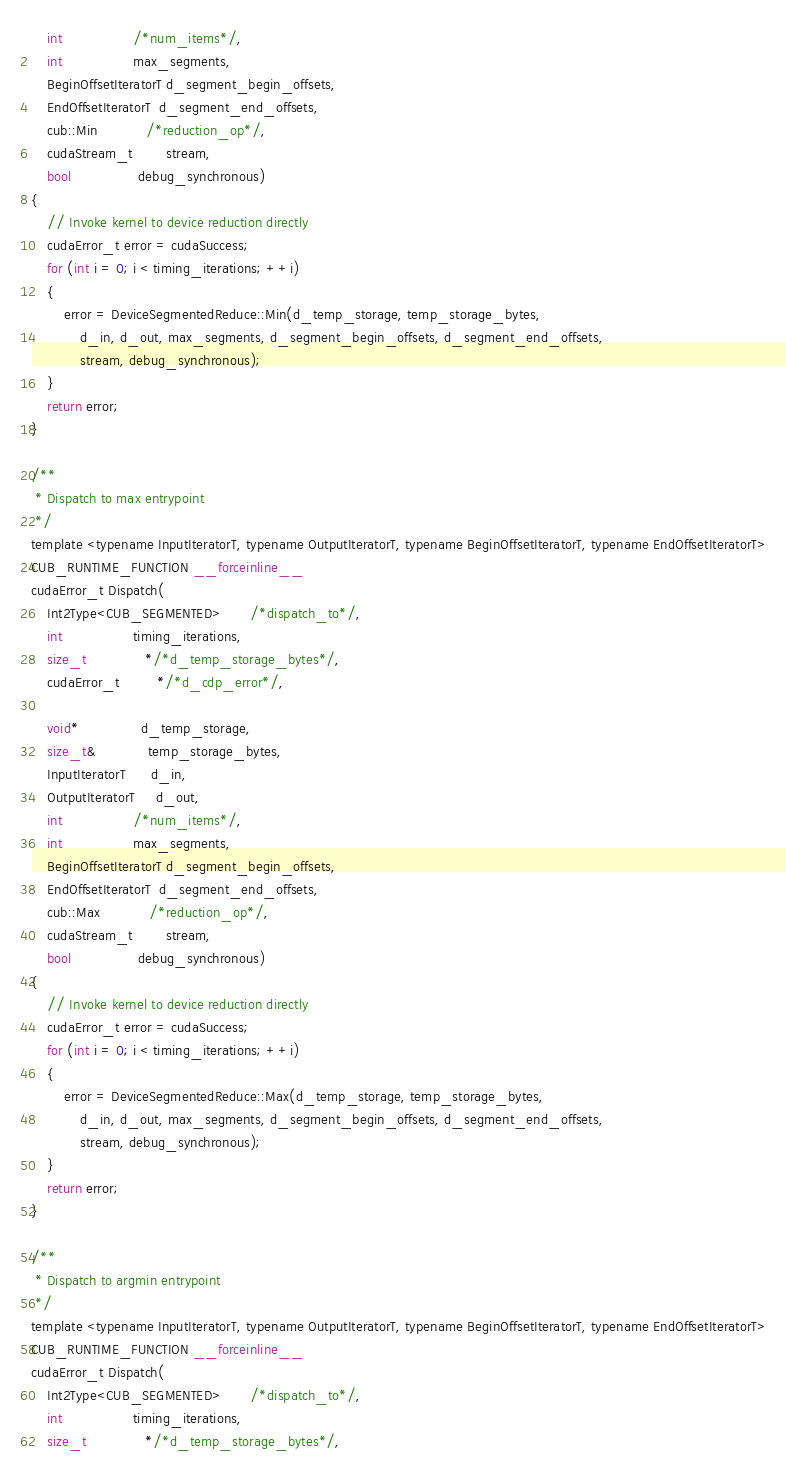<code> <loc_0><loc_0><loc_500><loc_500><_Cuda_>    int                 /*num_items*/,
    int                 max_segments,
    BeginOffsetIteratorT d_segment_begin_offsets,
    EndOffsetIteratorT  d_segment_end_offsets,
    cub::Min            /*reduction_op*/,
    cudaStream_t        stream,
    bool                debug_synchronous)
{
    // Invoke kernel to device reduction directly
    cudaError_t error = cudaSuccess;
    for (int i = 0; i < timing_iterations; ++i)
    {
        error = DeviceSegmentedReduce::Min(d_temp_storage, temp_storage_bytes,
            d_in, d_out, max_segments, d_segment_begin_offsets, d_segment_end_offsets,
            stream, debug_synchronous);
    }
    return error;
}

/**
 * Dispatch to max entrypoint
 */
template <typename InputIteratorT, typename OutputIteratorT, typename BeginOffsetIteratorT, typename EndOffsetIteratorT>
CUB_RUNTIME_FUNCTION __forceinline__
cudaError_t Dispatch(
    Int2Type<CUB_SEGMENTED>       /*dispatch_to*/,
    int                 timing_iterations,
    size_t              */*d_temp_storage_bytes*/,
    cudaError_t         */*d_cdp_error*/,

    void*               d_temp_storage,
    size_t&             temp_storage_bytes,
    InputIteratorT      d_in,
    OutputIteratorT     d_out,
    int                 /*num_items*/,
    int                 max_segments,
    BeginOffsetIteratorT d_segment_begin_offsets,
    EndOffsetIteratorT  d_segment_end_offsets,
    cub::Max            /*reduction_op*/,
    cudaStream_t        stream,
    bool                debug_synchronous)
{
    // Invoke kernel to device reduction directly
    cudaError_t error = cudaSuccess;
    for (int i = 0; i < timing_iterations; ++i)
    {
        error = DeviceSegmentedReduce::Max(d_temp_storage, temp_storage_bytes,
            d_in, d_out, max_segments, d_segment_begin_offsets, d_segment_end_offsets,
            stream, debug_synchronous);
    }
    return error;
}

/**
 * Dispatch to argmin entrypoint
 */
template <typename InputIteratorT, typename OutputIteratorT, typename BeginOffsetIteratorT, typename EndOffsetIteratorT>
CUB_RUNTIME_FUNCTION __forceinline__
cudaError_t Dispatch(
    Int2Type<CUB_SEGMENTED>       /*dispatch_to*/,
    int                 timing_iterations,
    size_t              */*d_temp_storage_bytes*/,</code> 